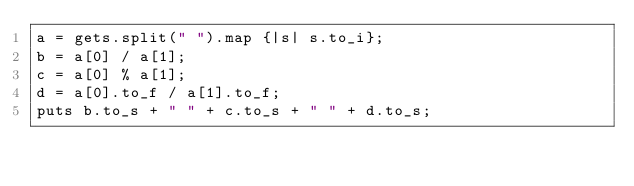Convert code to text. <code><loc_0><loc_0><loc_500><loc_500><_Ruby_>a = gets.split(" ").map {|s| s.to_i};
b = a[0] / a[1];
c = a[0] % a[1];
d = a[0].to_f / a[1].to_f;
puts b.to_s + " " + c.to_s + " " + d.to_s;</code> 